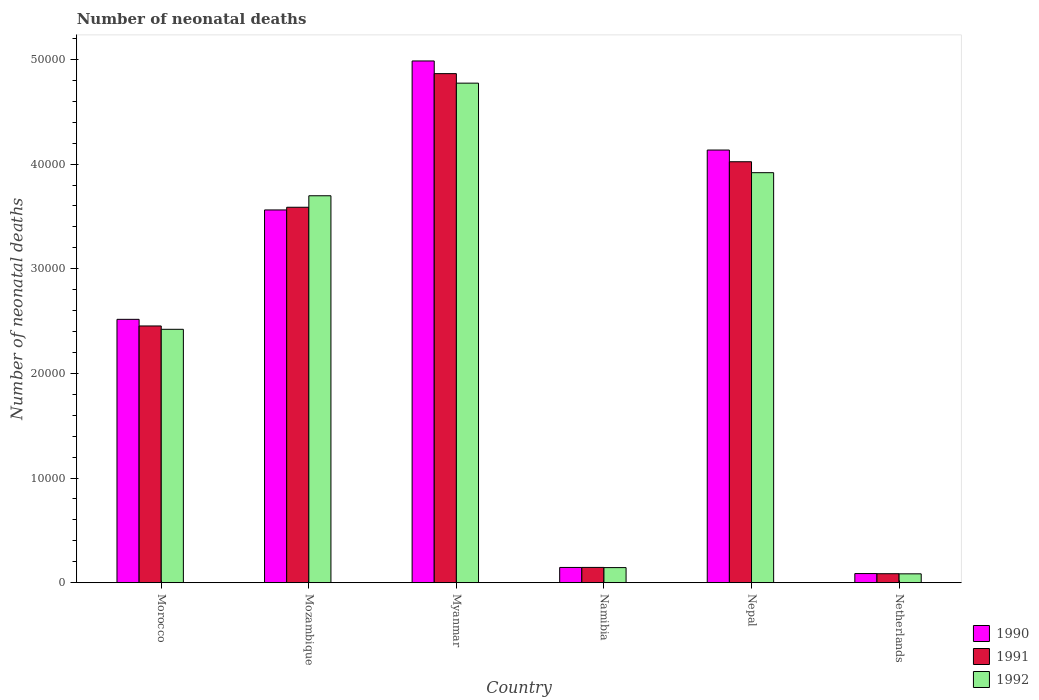How many different coloured bars are there?
Keep it short and to the point. 3. How many groups of bars are there?
Offer a terse response. 6. Are the number of bars per tick equal to the number of legend labels?
Keep it short and to the point. Yes. How many bars are there on the 5th tick from the left?
Your answer should be very brief. 3. What is the label of the 2nd group of bars from the left?
Your response must be concise. Mozambique. In how many cases, is the number of bars for a given country not equal to the number of legend labels?
Give a very brief answer. 0. What is the number of neonatal deaths in in 1990 in Namibia?
Provide a succinct answer. 1458. Across all countries, what is the maximum number of neonatal deaths in in 1991?
Give a very brief answer. 4.86e+04. Across all countries, what is the minimum number of neonatal deaths in in 1992?
Offer a terse response. 848. In which country was the number of neonatal deaths in in 1991 maximum?
Offer a terse response. Myanmar. In which country was the number of neonatal deaths in in 1991 minimum?
Keep it short and to the point. Netherlands. What is the total number of neonatal deaths in in 1992 in the graph?
Ensure brevity in your answer.  1.50e+05. What is the difference between the number of neonatal deaths in in 1990 in Morocco and that in Nepal?
Ensure brevity in your answer.  -1.62e+04. What is the difference between the number of neonatal deaths in in 1992 in Nepal and the number of neonatal deaths in in 1990 in Netherlands?
Your answer should be compact. 3.83e+04. What is the average number of neonatal deaths in in 1991 per country?
Provide a short and direct response. 2.53e+04. What is the difference between the number of neonatal deaths in of/in 1990 and number of neonatal deaths in of/in 1991 in Mozambique?
Make the answer very short. -256. In how many countries, is the number of neonatal deaths in in 1991 greater than 6000?
Your answer should be compact. 4. What is the ratio of the number of neonatal deaths in in 1991 in Mozambique to that in Myanmar?
Give a very brief answer. 0.74. What is the difference between the highest and the second highest number of neonatal deaths in in 1990?
Your answer should be very brief. 5723. What is the difference between the highest and the lowest number of neonatal deaths in in 1990?
Keep it short and to the point. 4.90e+04. In how many countries, is the number of neonatal deaths in in 1990 greater than the average number of neonatal deaths in in 1990 taken over all countries?
Keep it short and to the point. 3. What does the 2nd bar from the left in Myanmar represents?
Provide a short and direct response. 1991. What does the 3rd bar from the right in Myanmar represents?
Your answer should be very brief. 1990. Is it the case that in every country, the sum of the number of neonatal deaths in in 1990 and number of neonatal deaths in in 1991 is greater than the number of neonatal deaths in in 1992?
Give a very brief answer. Yes. Are all the bars in the graph horizontal?
Offer a very short reply. No. Are the values on the major ticks of Y-axis written in scientific E-notation?
Your answer should be compact. No. Does the graph contain any zero values?
Provide a short and direct response. No. Does the graph contain grids?
Provide a short and direct response. No. How are the legend labels stacked?
Your answer should be very brief. Vertical. What is the title of the graph?
Give a very brief answer. Number of neonatal deaths. What is the label or title of the X-axis?
Provide a succinct answer. Country. What is the label or title of the Y-axis?
Provide a short and direct response. Number of neonatal deaths. What is the Number of neonatal deaths in 1990 in Morocco?
Your response must be concise. 2.52e+04. What is the Number of neonatal deaths of 1991 in Morocco?
Ensure brevity in your answer.  2.45e+04. What is the Number of neonatal deaths of 1992 in Morocco?
Offer a very short reply. 2.42e+04. What is the Number of neonatal deaths of 1990 in Mozambique?
Your response must be concise. 3.56e+04. What is the Number of neonatal deaths in 1991 in Mozambique?
Give a very brief answer. 3.59e+04. What is the Number of neonatal deaths of 1992 in Mozambique?
Provide a succinct answer. 3.70e+04. What is the Number of neonatal deaths of 1990 in Myanmar?
Provide a succinct answer. 4.99e+04. What is the Number of neonatal deaths of 1991 in Myanmar?
Keep it short and to the point. 4.86e+04. What is the Number of neonatal deaths of 1992 in Myanmar?
Offer a very short reply. 4.77e+04. What is the Number of neonatal deaths of 1990 in Namibia?
Provide a succinct answer. 1458. What is the Number of neonatal deaths of 1991 in Namibia?
Ensure brevity in your answer.  1462. What is the Number of neonatal deaths of 1992 in Namibia?
Make the answer very short. 1443. What is the Number of neonatal deaths of 1990 in Nepal?
Make the answer very short. 4.13e+04. What is the Number of neonatal deaths of 1991 in Nepal?
Offer a terse response. 4.02e+04. What is the Number of neonatal deaths of 1992 in Nepal?
Your answer should be very brief. 3.92e+04. What is the Number of neonatal deaths of 1990 in Netherlands?
Your answer should be very brief. 874. What is the Number of neonatal deaths in 1991 in Netherlands?
Your answer should be very brief. 860. What is the Number of neonatal deaths of 1992 in Netherlands?
Offer a very short reply. 848. Across all countries, what is the maximum Number of neonatal deaths in 1990?
Offer a terse response. 4.99e+04. Across all countries, what is the maximum Number of neonatal deaths of 1991?
Offer a very short reply. 4.86e+04. Across all countries, what is the maximum Number of neonatal deaths of 1992?
Your response must be concise. 4.77e+04. Across all countries, what is the minimum Number of neonatal deaths in 1990?
Provide a succinct answer. 874. Across all countries, what is the minimum Number of neonatal deaths in 1991?
Your answer should be very brief. 860. Across all countries, what is the minimum Number of neonatal deaths in 1992?
Provide a succinct answer. 848. What is the total Number of neonatal deaths of 1990 in the graph?
Provide a succinct answer. 1.54e+05. What is the total Number of neonatal deaths of 1991 in the graph?
Your response must be concise. 1.52e+05. What is the total Number of neonatal deaths of 1992 in the graph?
Provide a short and direct response. 1.50e+05. What is the difference between the Number of neonatal deaths in 1990 in Morocco and that in Mozambique?
Keep it short and to the point. -1.05e+04. What is the difference between the Number of neonatal deaths of 1991 in Morocco and that in Mozambique?
Provide a succinct answer. -1.13e+04. What is the difference between the Number of neonatal deaths in 1992 in Morocco and that in Mozambique?
Provide a short and direct response. -1.28e+04. What is the difference between the Number of neonatal deaths in 1990 in Morocco and that in Myanmar?
Ensure brevity in your answer.  -2.47e+04. What is the difference between the Number of neonatal deaths of 1991 in Morocco and that in Myanmar?
Offer a terse response. -2.41e+04. What is the difference between the Number of neonatal deaths of 1992 in Morocco and that in Myanmar?
Give a very brief answer. -2.35e+04. What is the difference between the Number of neonatal deaths in 1990 in Morocco and that in Namibia?
Provide a short and direct response. 2.37e+04. What is the difference between the Number of neonatal deaths in 1991 in Morocco and that in Namibia?
Ensure brevity in your answer.  2.31e+04. What is the difference between the Number of neonatal deaths in 1992 in Morocco and that in Namibia?
Your answer should be very brief. 2.28e+04. What is the difference between the Number of neonatal deaths of 1990 in Morocco and that in Nepal?
Offer a very short reply. -1.62e+04. What is the difference between the Number of neonatal deaths of 1991 in Morocco and that in Nepal?
Provide a succinct answer. -1.57e+04. What is the difference between the Number of neonatal deaths in 1992 in Morocco and that in Nepal?
Provide a succinct answer. -1.50e+04. What is the difference between the Number of neonatal deaths of 1990 in Morocco and that in Netherlands?
Provide a succinct answer. 2.43e+04. What is the difference between the Number of neonatal deaths of 1991 in Morocco and that in Netherlands?
Offer a terse response. 2.37e+04. What is the difference between the Number of neonatal deaths of 1992 in Morocco and that in Netherlands?
Your response must be concise. 2.34e+04. What is the difference between the Number of neonatal deaths in 1990 in Mozambique and that in Myanmar?
Your answer should be very brief. -1.42e+04. What is the difference between the Number of neonatal deaths of 1991 in Mozambique and that in Myanmar?
Provide a short and direct response. -1.28e+04. What is the difference between the Number of neonatal deaths of 1992 in Mozambique and that in Myanmar?
Keep it short and to the point. -1.08e+04. What is the difference between the Number of neonatal deaths of 1990 in Mozambique and that in Namibia?
Make the answer very short. 3.42e+04. What is the difference between the Number of neonatal deaths of 1991 in Mozambique and that in Namibia?
Your response must be concise. 3.44e+04. What is the difference between the Number of neonatal deaths of 1992 in Mozambique and that in Namibia?
Your response must be concise. 3.55e+04. What is the difference between the Number of neonatal deaths in 1990 in Mozambique and that in Nepal?
Your answer should be very brief. -5723. What is the difference between the Number of neonatal deaths of 1991 in Mozambique and that in Nepal?
Your response must be concise. -4349. What is the difference between the Number of neonatal deaths of 1992 in Mozambique and that in Nepal?
Your response must be concise. -2205. What is the difference between the Number of neonatal deaths in 1990 in Mozambique and that in Netherlands?
Offer a terse response. 3.47e+04. What is the difference between the Number of neonatal deaths in 1991 in Mozambique and that in Netherlands?
Provide a short and direct response. 3.50e+04. What is the difference between the Number of neonatal deaths in 1992 in Mozambique and that in Netherlands?
Your response must be concise. 3.61e+04. What is the difference between the Number of neonatal deaths of 1990 in Myanmar and that in Namibia?
Offer a terse response. 4.84e+04. What is the difference between the Number of neonatal deaths in 1991 in Myanmar and that in Namibia?
Offer a very short reply. 4.72e+04. What is the difference between the Number of neonatal deaths in 1992 in Myanmar and that in Namibia?
Your answer should be compact. 4.63e+04. What is the difference between the Number of neonatal deaths of 1990 in Myanmar and that in Nepal?
Keep it short and to the point. 8512. What is the difference between the Number of neonatal deaths in 1991 in Myanmar and that in Nepal?
Provide a short and direct response. 8419. What is the difference between the Number of neonatal deaths in 1992 in Myanmar and that in Nepal?
Your response must be concise. 8554. What is the difference between the Number of neonatal deaths of 1990 in Myanmar and that in Netherlands?
Provide a succinct answer. 4.90e+04. What is the difference between the Number of neonatal deaths in 1991 in Myanmar and that in Netherlands?
Your answer should be compact. 4.78e+04. What is the difference between the Number of neonatal deaths in 1992 in Myanmar and that in Netherlands?
Offer a very short reply. 4.69e+04. What is the difference between the Number of neonatal deaths in 1990 in Namibia and that in Nepal?
Your answer should be very brief. -3.99e+04. What is the difference between the Number of neonatal deaths in 1991 in Namibia and that in Nepal?
Make the answer very short. -3.88e+04. What is the difference between the Number of neonatal deaths in 1992 in Namibia and that in Nepal?
Make the answer very short. -3.77e+04. What is the difference between the Number of neonatal deaths in 1990 in Namibia and that in Netherlands?
Give a very brief answer. 584. What is the difference between the Number of neonatal deaths of 1991 in Namibia and that in Netherlands?
Provide a succinct answer. 602. What is the difference between the Number of neonatal deaths in 1992 in Namibia and that in Netherlands?
Offer a very short reply. 595. What is the difference between the Number of neonatal deaths of 1990 in Nepal and that in Netherlands?
Your answer should be very brief. 4.05e+04. What is the difference between the Number of neonatal deaths of 1991 in Nepal and that in Netherlands?
Keep it short and to the point. 3.94e+04. What is the difference between the Number of neonatal deaths of 1992 in Nepal and that in Netherlands?
Provide a short and direct response. 3.83e+04. What is the difference between the Number of neonatal deaths in 1990 in Morocco and the Number of neonatal deaths in 1991 in Mozambique?
Give a very brief answer. -1.07e+04. What is the difference between the Number of neonatal deaths in 1990 in Morocco and the Number of neonatal deaths in 1992 in Mozambique?
Provide a succinct answer. -1.18e+04. What is the difference between the Number of neonatal deaths in 1991 in Morocco and the Number of neonatal deaths in 1992 in Mozambique?
Offer a very short reply. -1.24e+04. What is the difference between the Number of neonatal deaths in 1990 in Morocco and the Number of neonatal deaths in 1991 in Myanmar?
Your answer should be very brief. -2.35e+04. What is the difference between the Number of neonatal deaths in 1990 in Morocco and the Number of neonatal deaths in 1992 in Myanmar?
Make the answer very short. -2.26e+04. What is the difference between the Number of neonatal deaths in 1991 in Morocco and the Number of neonatal deaths in 1992 in Myanmar?
Provide a short and direct response. -2.32e+04. What is the difference between the Number of neonatal deaths of 1990 in Morocco and the Number of neonatal deaths of 1991 in Namibia?
Ensure brevity in your answer.  2.37e+04. What is the difference between the Number of neonatal deaths in 1990 in Morocco and the Number of neonatal deaths in 1992 in Namibia?
Provide a short and direct response. 2.37e+04. What is the difference between the Number of neonatal deaths of 1991 in Morocco and the Number of neonatal deaths of 1992 in Namibia?
Make the answer very short. 2.31e+04. What is the difference between the Number of neonatal deaths in 1990 in Morocco and the Number of neonatal deaths in 1991 in Nepal?
Make the answer very short. -1.51e+04. What is the difference between the Number of neonatal deaths of 1990 in Morocco and the Number of neonatal deaths of 1992 in Nepal?
Provide a succinct answer. -1.40e+04. What is the difference between the Number of neonatal deaths of 1991 in Morocco and the Number of neonatal deaths of 1992 in Nepal?
Provide a short and direct response. -1.46e+04. What is the difference between the Number of neonatal deaths of 1990 in Morocco and the Number of neonatal deaths of 1991 in Netherlands?
Your response must be concise. 2.43e+04. What is the difference between the Number of neonatal deaths in 1990 in Morocco and the Number of neonatal deaths in 1992 in Netherlands?
Offer a terse response. 2.43e+04. What is the difference between the Number of neonatal deaths in 1991 in Morocco and the Number of neonatal deaths in 1992 in Netherlands?
Offer a very short reply. 2.37e+04. What is the difference between the Number of neonatal deaths of 1990 in Mozambique and the Number of neonatal deaths of 1991 in Myanmar?
Your answer should be very brief. -1.30e+04. What is the difference between the Number of neonatal deaths in 1990 in Mozambique and the Number of neonatal deaths in 1992 in Myanmar?
Your answer should be compact. -1.21e+04. What is the difference between the Number of neonatal deaths in 1991 in Mozambique and the Number of neonatal deaths in 1992 in Myanmar?
Your answer should be compact. -1.19e+04. What is the difference between the Number of neonatal deaths of 1990 in Mozambique and the Number of neonatal deaths of 1991 in Namibia?
Provide a succinct answer. 3.42e+04. What is the difference between the Number of neonatal deaths in 1990 in Mozambique and the Number of neonatal deaths in 1992 in Namibia?
Keep it short and to the point. 3.42e+04. What is the difference between the Number of neonatal deaths of 1991 in Mozambique and the Number of neonatal deaths of 1992 in Namibia?
Provide a succinct answer. 3.44e+04. What is the difference between the Number of neonatal deaths in 1990 in Mozambique and the Number of neonatal deaths in 1991 in Nepal?
Provide a succinct answer. -4605. What is the difference between the Number of neonatal deaths of 1990 in Mozambique and the Number of neonatal deaths of 1992 in Nepal?
Your answer should be very brief. -3561. What is the difference between the Number of neonatal deaths in 1991 in Mozambique and the Number of neonatal deaths in 1992 in Nepal?
Your response must be concise. -3305. What is the difference between the Number of neonatal deaths of 1990 in Mozambique and the Number of neonatal deaths of 1991 in Netherlands?
Your answer should be very brief. 3.48e+04. What is the difference between the Number of neonatal deaths of 1990 in Mozambique and the Number of neonatal deaths of 1992 in Netherlands?
Ensure brevity in your answer.  3.48e+04. What is the difference between the Number of neonatal deaths of 1991 in Mozambique and the Number of neonatal deaths of 1992 in Netherlands?
Offer a very short reply. 3.50e+04. What is the difference between the Number of neonatal deaths in 1990 in Myanmar and the Number of neonatal deaths in 1991 in Namibia?
Your answer should be very brief. 4.84e+04. What is the difference between the Number of neonatal deaths in 1990 in Myanmar and the Number of neonatal deaths in 1992 in Namibia?
Your response must be concise. 4.84e+04. What is the difference between the Number of neonatal deaths in 1991 in Myanmar and the Number of neonatal deaths in 1992 in Namibia?
Offer a very short reply. 4.72e+04. What is the difference between the Number of neonatal deaths in 1990 in Myanmar and the Number of neonatal deaths in 1991 in Nepal?
Offer a very short reply. 9630. What is the difference between the Number of neonatal deaths of 1990 in Myanmar and the Number of neonatal deaths of 1992 in Nepal?
Provide a succinct answer. 1.07e+04. What is the difference between the Number of neonatal deaths in 1991 in Myanmar and the Number of neonatal deaths in 1992 in Nepal?
Give a very brief answer. 9463. What is the difference between the Number of neonatal deaths of 1990 in Myanmar and the Number of neonatal deaths of 1991 in Netherlands?
Your answer should be compact. 4.90e+04. What is the difference between the Number of neonatal deaths in 1990 in Myanmar and the Number of neonatal deaths in 1992 in Netherlands?
Give a very brief answer. 4.90e+04. What is the difference between the Number of neonatal deaths in 1991 in Myanmar and the Number of neonatal deaths in 1992 in Netherlands?
Your answer should be compact. 4.78e+04. What is the difference between the Number of neonatal deaths in 1990 in Namibia and the Number of neonatal deaths in 1991 in Nepal?
Keep it short and to the point. -3.88e+04. What is the difference between the Number of neonatal deaths in 1990 in Namibia and the Number of neonatal deaths in 1992 in Nepal?
Offer a terse response. -3.77e+04. What is the difference between the Number of neonatal deaths of 1991 in Namibia and the Number of neonatal deaths of 1992 in Nepal?
Offer a very short reply. -3.77e+04. What is the difference between the Number of neonatal deaths of 1990 in Namibia and the Number of neonatal deaths of 1991 in Netherlands?
Keep it short and to the point. 598. What is the difference between the Number of neonatal deaths in 1990 in Namibia and the Number of neonatal deaths in 1992 in Netherlands?
Your answer should be compact. 610. What is the difference between the Number of neonatal deaths of 1991 in Namibia and the Number of neonatal deaths of 1992 in Netherlands?
Your answer should be very brief. 614. What is the difference between the Number of neonatal deaths of 1990 in Nepal and the Number of neonatal deaths of 1991 in Netherlands?
Offer a terse response. 4.05e+04. What is the difference between the Number of neonatal deaths in 1990 in Nepal and the Number of neonatal deaths in 1992 in Netherlands?
Keep it short and to the point. 4.05e+04. What is the difference between the Number of neonatal deaths of 1991 in Nepal and the Number of neonatal deaths of 1992 in Netherlands?
Give a very brief answer. 3.94e+04. What is the average Number of neonatal deaths in 1990 per country?
Provide a succinct answer. 2.57e+04. What is the average Number of neonatal deaths of 1991 per country?
Ensure brevity in your answer.  2.53e+04. What is the average Number of neonatal deaths of 1992 per country?
Your response must be concise. 2.51e+04. What is the difference between the Number of neonatal deaths of 1990 and Number of neonatal deaths of 1991 in Morocco?
Provide a succinct answer. 634. What is the difference between the Number of neonatal deaths in 1990 and Number of neonatal deaths in 1992 in Morocco?
Keep it short and to the point. 953. What is the difference between the Number of neonatal deaths of 1991 and Number of neonatal deaths of 1992 in Morocco?
Give a very brief answer. 319. What is the difference between the Number of neonatal deaths of 1990 and Number of neonatal deaths of 1991 in Mozambique?
Keep it short and to the point. -256. What is the difference between the Number of neonatal deaths in 1990 and Number of neonatal deaths in 1992 in Mozambique?
Your response must be concise. -1356. What is the difference between the Number of neonatal deaths of 1991 and Number of neonatal deaths of 1992 in Mozambique?
Give a very brief answer. -1100. What is the difference between the Number of neonatal deaths of 1990 and Number of neonatal deaths of 1991 in Myanmar?
Your response must be concise. 1211. What is the difference between the Number of neonatal deaths in 1990 and Number of neonatal deaths in 1992 in Myanmar?
Your answer should be very brief. 2120. What is the difference between the Number of neonatal deaths of 1991 and Number of neonatal deaths of 1992 in Myanmar?
Your answer should be compact. 909. What is the difference between the Number of neonatal deaths in 1990 and Number of neonatal deaths in 1992 in Namibia?
Offer a terse response. 15. What is the difference between the Number of neonatal deaths in 1991 and Number of neonatal deaths in 1992 in Namibia?
Your answer should be very brief. 19. What is the difference between the Number of neonatal deaths in 1990 and Number of neonatal deaths in 1991 in Nepal?
Make the answer very short. 1118. What is the difference between the Number of neonatal deaths of 1990 and Number of neonatal deaths of 1992 in Nepal?
Your answer should be very brief. 2162. What is the difference between the Number of neonatal deaths of 1991 and Number of neonatal deaths of 1992 in Nepal?
Your answer should be compact. 1044. What is the difference between the Number of neonatal deaths in 1990 and Number of neonatal deaths in 1992 in Netherlands?
Provide a succinct answer. 26. What is the ratio of the Number of neonatal deaths in 1990 in Morocco to that in Mozambique?
Provide a succinct answer. 0.71. What is the ratio of the Number of neonatal deaths in 1991 in Morocco to that in Mozambique?
Make the answer very short. 0.68. What is the ratio of the Number of neonatal deaths of 1992 in Morocco to that in Mozambique?
Your answer should be very brief. 0.65. What is the ratio of the Number of neonatal deaths of 1990 in Morocco to that in Myanmar?
Make the answer very short. 0.5. What is the ratio of the Number of neonatal deaths in 1991 in Morocco to that in Myanmar?
Provide a short and direct response. 0.5. What is the ratio of the Number of neonatal deaths of 1992 in Morocco to that in Myanmar?
Make the answer very short. 0.51. What is the ratio of the Number of neonatal deaths in 1990 in Morocco to that in Namibia?
Offer a terse response. 17.26. What is the ratio of the Number of neonatal deaths in 1991 in Morocco to that in Namibia?
Keep it short and to the point. 16.78. What is the ratio of the Number of neonatal deaths of 1992 in Morocco to that in Namibia?
Ensure brevity in your answer.  16.78. What is the ratio of the Number of neonatal deaths in 1990 in Morocco to that in Nepal?
Offer a terse response. 0.61. What is the ratio of the Number of neonatal deaths of 1991 in Morocco to that in Nepal?
Your response must be concise. 0.61. What is the ratio of the Number of neonatal deaths of 1992 in Morocco to that in Nepal?
Your answer should be very brief. 0.62. What is the ratio of the Number of neonatal deaths of 1990 in Morocco to that in Netherlands?
Provide a short and direct response. 28.79. What is the ratio of the Number of neonatal deaths of 1991 in Morocco to that in Netherlands?
Provide a succinct answer. 28.53. What is the ratio of the Number of neonatal deaths in 1992 in Morocco to that in Netherlands?
Your answer should be compact. 28.55. What is the ratio of the Number of neonatal deaths in 1990 in Mozambique to that in Myanmar?
Give a very brief answer. 0.71. What is the ratio of the Number of neonatal deaths in 1991 in Mozambique to that in Myanmar?
Your response must be concise. 0.74. What is the ratio of the Number of neonatal deaths of 1992 in Mozambique to that in Myanmar?
Offer a terse response. 0.77. What is the ratio of the Number of neonatal deaths of 1990 in Mozambique to that in Namibia?
Your answer should be very brief. 24.43. What is the ratio of the Number of neonatal deaths in 1991 in Mozambique to that in Namibia?
Ensure brevity in your answer.  24.54. What is the ratio of the Number of neonatal deaths in 1992 in Mozambique to that in Namibia?
Provide a succinct answer. 25.62. What is the ratio of the Number of neonatal deaths in 1990 in Mozambique to that in Nepal?
Your answer should be compact. 0.86. What is the ratio of the Number of neonatal deaths of 1991 in Mozambique to that in Nepal?
Keep it short and to the point. 0.89. What is the ratio of the Number of neonatal deaths in 1992 in Mozambique to that in Nepal?
Offer a very short reply. 0.94. What is the ratio of the Number of neonatal deaths of 1990 in Mozambique to that in Netherlands?
Make the answer very short. 40.75. What is the ratio of the Number of neonatal deaths of 1991 in Mozambique to that in Netherlands?
Your answer should be compact. 41.71. What is the ratio of the Number of neonatal deaths in 1992 in Mozambique to that in Netherlands?
Offer a very short reply. 43.6. What is the ratio of the Number of neonatal deaths of 1990 in Myanmar to that in Namibia?
Make the answer very short. 34.19. What is the ratio of the Number of neonatal deaths of 1991 in Myanmar to that in Namibia?
Your response must be concise. 33.27. What is the ratio of the Number of neonatal deaths of 1992 in Myanmar to that in Namibia?
Offer a very short reply. 33.08. What is the ratio of the Number of neonatal deaths of 1990 in Myanmar to that in Nepal?
Make the answer very short. 1.21. What is the ratio of the Number of neonatal deaths of 1991 in Myanmar to that in Nepal?
Your response must be concise. 1.21. What is the ratio of the Number of neonatal deaths in 1992 in Myanmar to that in Nepal?
Keep it short and to the point. 1.22. What is the ratio of the Number of neonatal deaths in 1990 in Myanmar to that in Netherlands?
Give a very brief answer. 57.04. What is the ratio of the Number of neonatal deaths in 1991 in Myanmar to that in Netherlands?
Provide a short and direct response. 56.56. What is the ratio of the Number of neonatal deaths of 1992 in Myanmar to that in Netherlands?
Offer a very short reply. 56.29. What is the ratio of the Number of neonatal deaths in 1990 in Namibia to that in Nepal?
Offer a terse response. 0.04. What is the ratio of the Number of neonatal deaths of 1991 in Namibia to that in Nepal?
Offer a very short reply. 0.04. What is the ratio of the Number of neonatal deaths in 1992 in Namibia to that in Nepal?
Give a very brief answer. 0.04. What is the ratio of the Number of neonatal deaths in 1990 in Namibia to that in Netherlands?
Offer a terse response. 1.67. What is the ratio of the Number of neonatal deaths in 1992 in Namibia to that in Netherlands?
Make the answer very short. 1.7. What is the ratio of the Number of neonatal deaths in 1990 in Nepal to that in Netherlands?
Keep it short and to the point. 47.3. What is the ratio of the Number of neonatal deaths in 1991 in Nepal to that in Netherlands?
Ensure brevity in your answer.  46.77. What is the ratio of the Number of neonatal deaths of 1992 in Nepal to that in Netherlands?
Ensure brevity in your answer.  46.2. What is the difference between the highest and the second highest Number of neonatal deaths in 1990?
Make the answer very short. 8512. What is the difference between the highest and the second highest Number of neonatal deaths of 1991?
Keep it short and to the point. 8419. What is the difference between the highest and the second highest Number of neonatal deaths in 1992?
Provide a short and direct response. 8554. What is the difference between the highest and the lowest Number of neonatal deaths of 1990?
Give a very brief answer. 4.90e+04. What is the difference between the highest and the lowest Number of neonatal deaths in 1991?
Give a very brief answer. 4.78e+04. What is the difference between the highest and the lowest Number of neonatal deaths in 1992?
Offer a very short reply. 4.69e+04. 